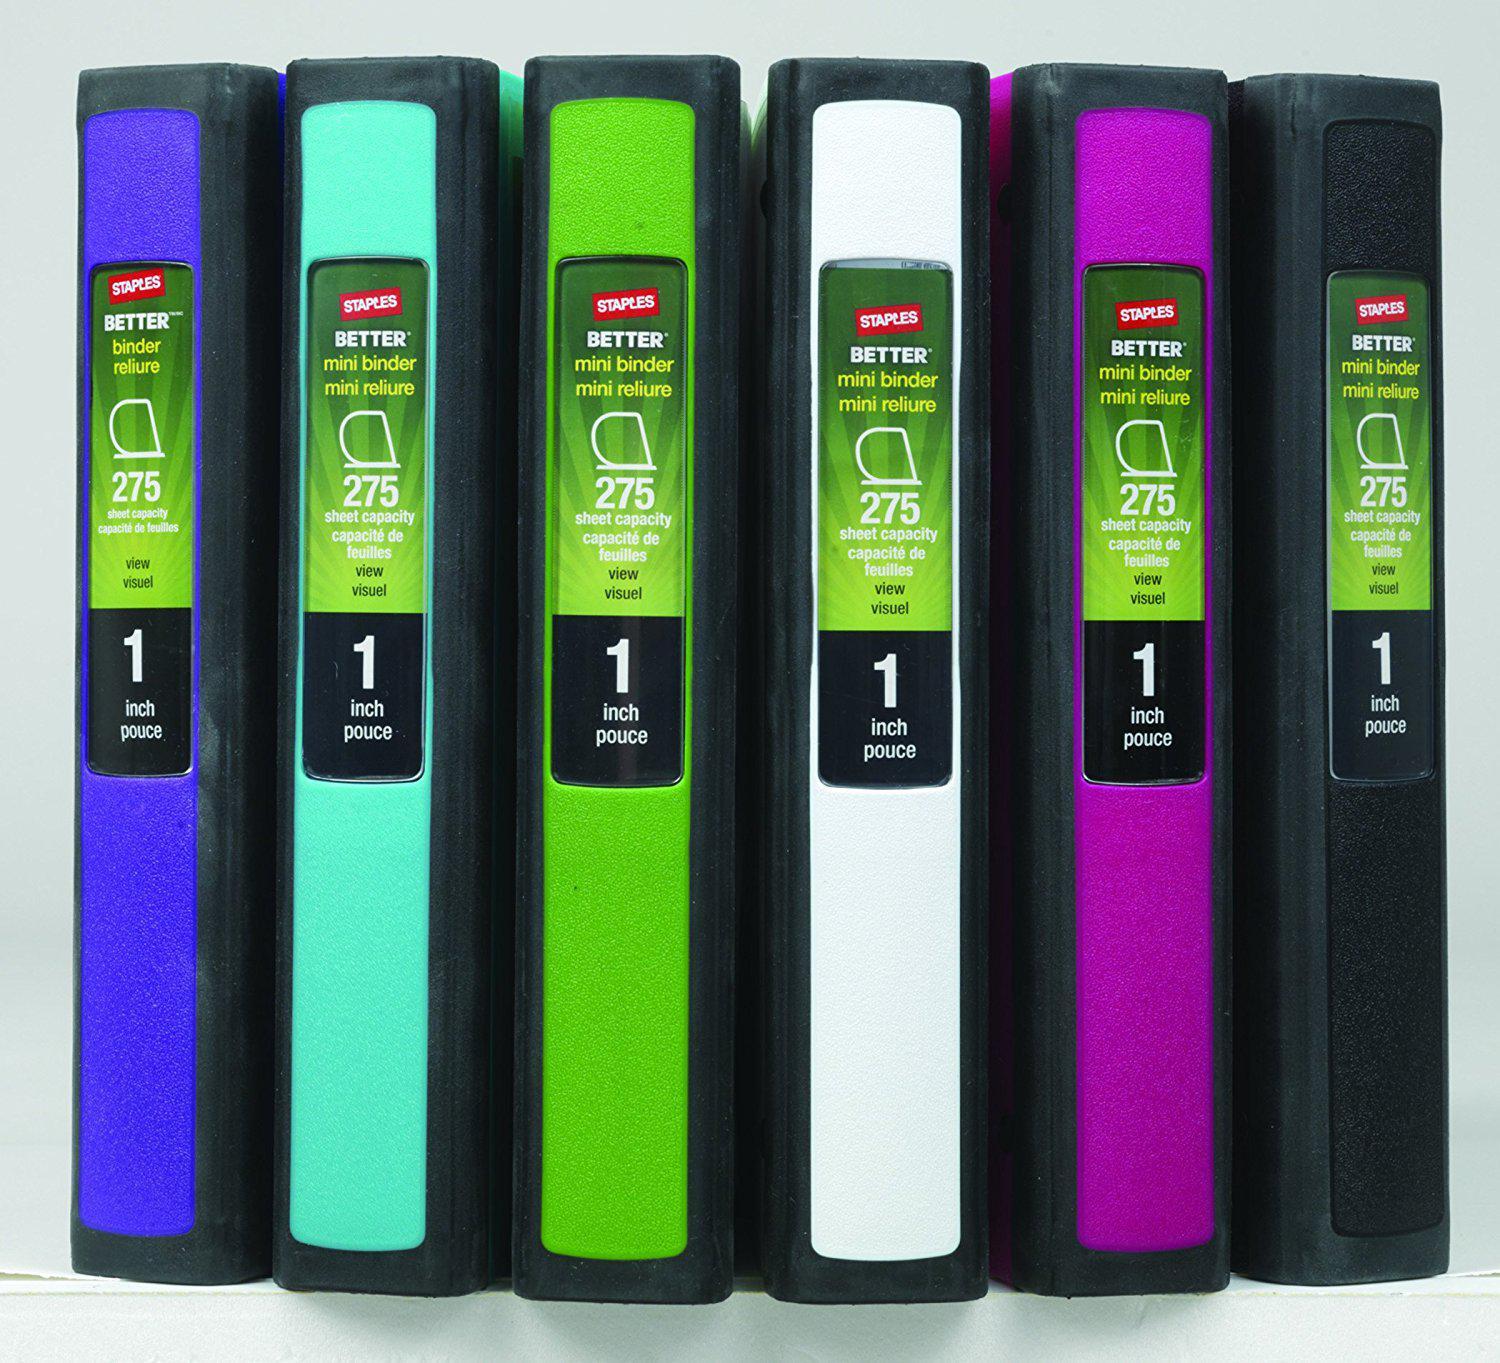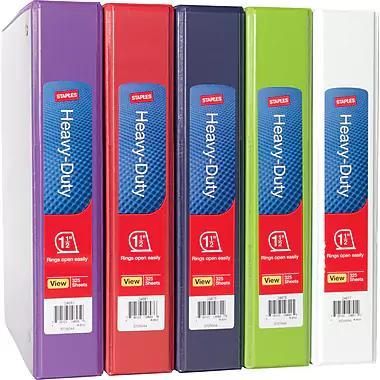The first image is the image on the left, the second image is the image on the right. For the images displayed, is the sentence "In one of the pictures, the white binder is between the black and red binders." factually correct? Answer yes or no. No. The first image is the image on the left, the second image is the image on the right. Assess this claim about the two images: "One image shows different colored binders displayed at some angle, instead of curved or straight ahead.". Correct or not? Answer yes or no. Yes. 